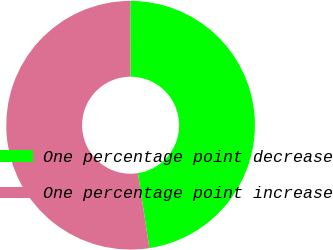Convert chart. <chart><loc_0><loc_0><loc_500><loc_500><pie_chart><fcel>One percentage point decrease<fcel>One percentage point increase<nl><fcel>47.62%<fcel>52.38%<nl></chart> 